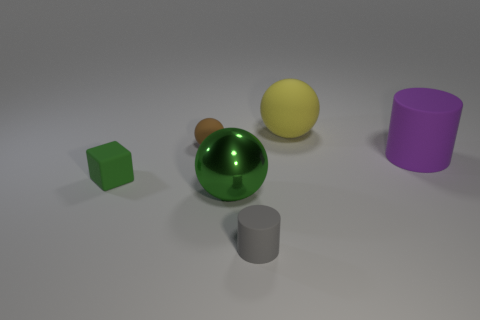Can you describe the shapes and colors present in the image? The image features a variety of geometric shapes in different colors: a green cube, a brown and green sphere, a yellow sphere, a grey cylinder, and a large purple cylinder. The objects cast soft shadows on a light grey background, suggesting a diffuse light source. 